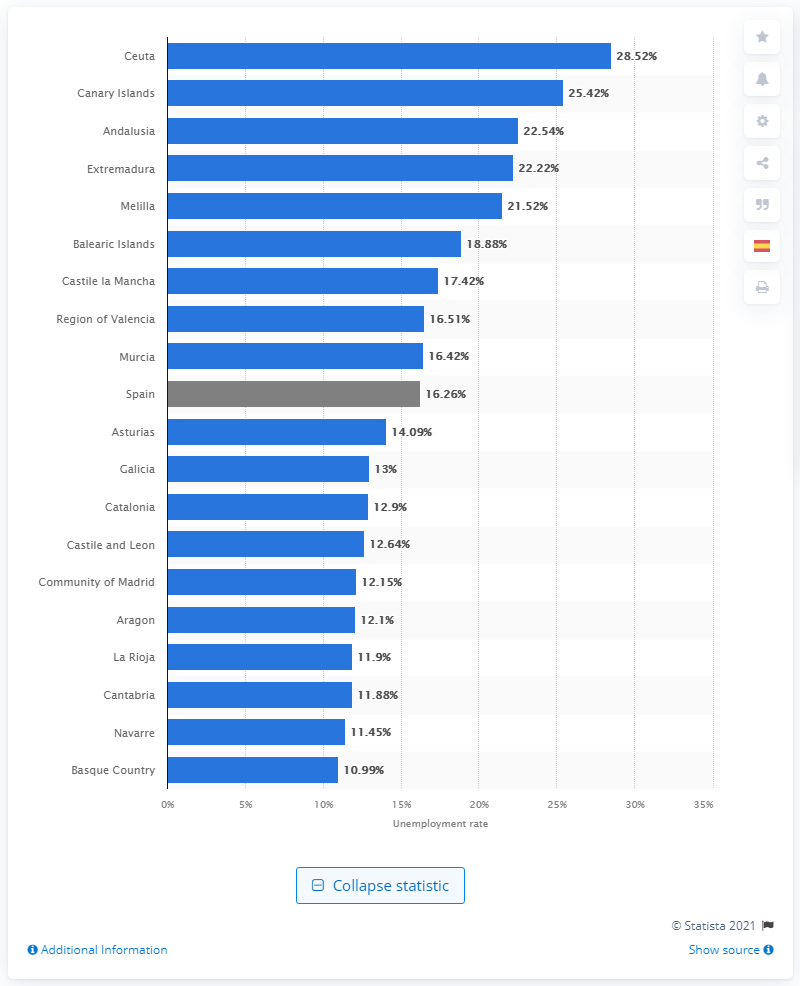What is the name of the southern region bordering Portugal? The southern region bordering Portugal as displayed in the image is Extremadura. Extremadura is known for its rich history, including Roman and Moorish influences, and its natural reserves. 